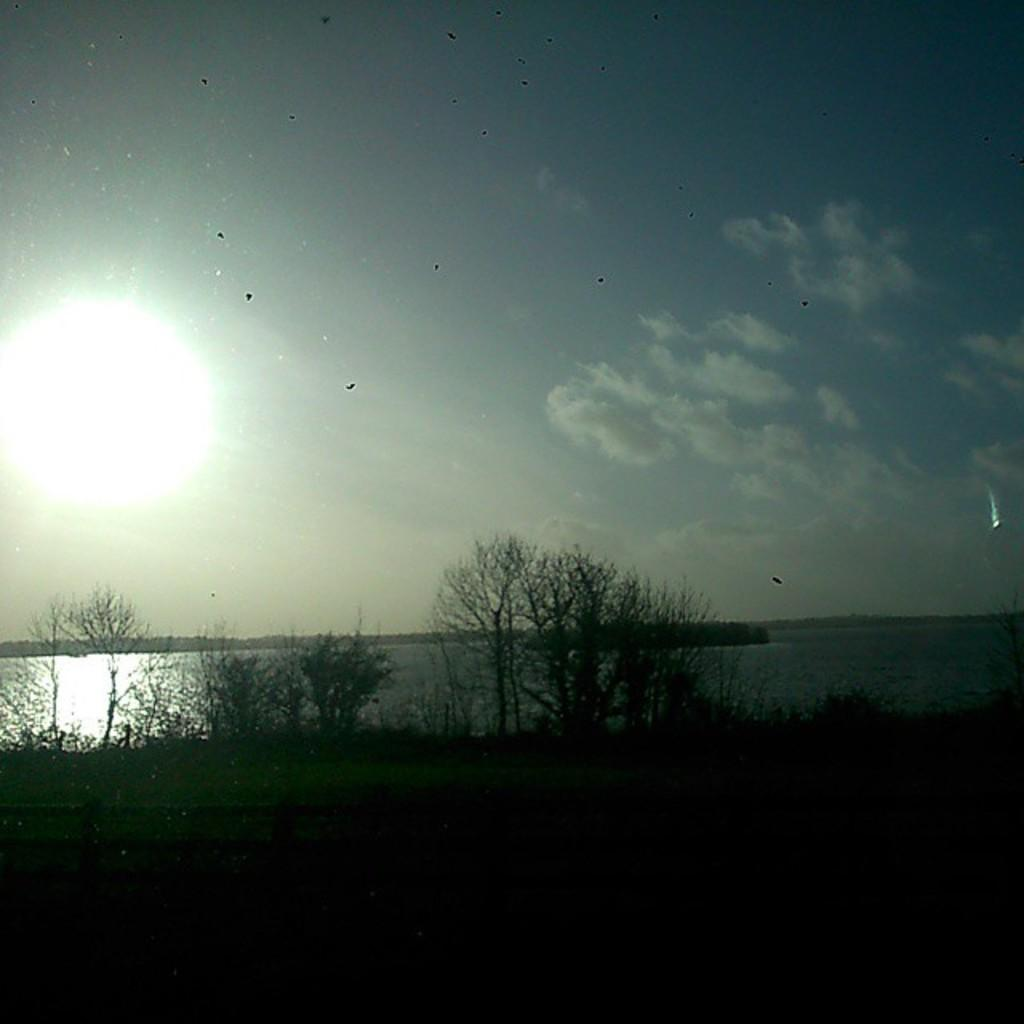What celestial body is located in the left corner of the image? There is a sun in the left corner of the image. What type of vegetation can be seen in the image? There are trees in the image. What natural element is visible in the image? There is water visible in the image. What type of pen is being used to draw the lace in the image? There is no pen or lace present in the image; it features a sun, trees, and water. 